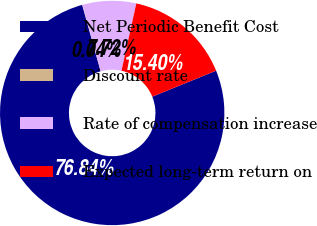<chart> <loc_0><loc_0><loc_500><loc_500><pie_chart><fcel>Net Periodic Benefit Cost<fcel>Discount rate<fcel>Rate of compensation increase<fcel>Expected long-term return on<nl><fcel>76.84%<fcel>0.04%<fcel>7.72%<fcel>15.4%<nl></chart> 